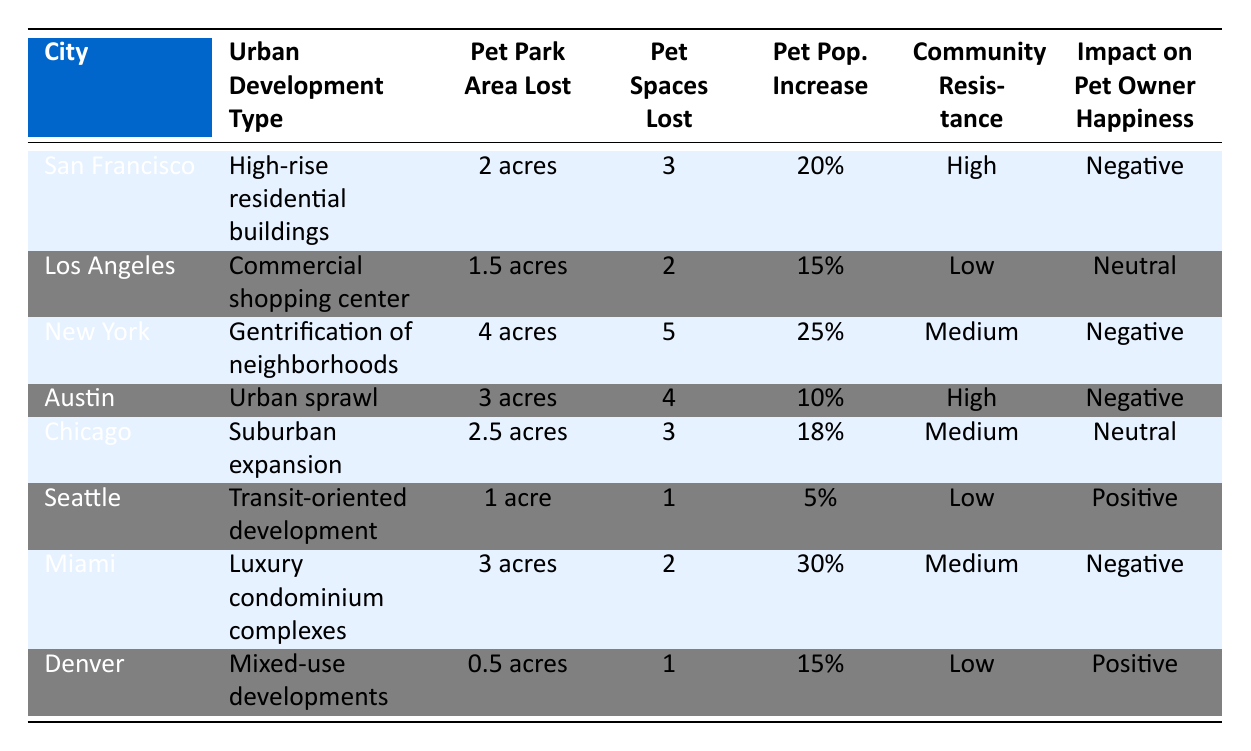What is the total pet park area lost in New York? From the table, the pet park area lost in New York is specified as 4 acres.
Answer: 4 acres How many pet friendly spaces were lost in Austin? The table indicates that 4 pet friendly spaces were lost in Austin.
Answer: 4 Which city experienced the highest increase in pet population? By comparing the increase in pet populations across cities, New York has the highest at 25%.
Answer: New York What's the average area of pet parks lost across all cities? To calculate the average, sum the pet park areas lost: (2 + 1.5 + 4 + 3 + 2.5 + 1 + 3 + 0.5) = 18.5 acres. There are 8 cities, so the average is 18.5/8 = 2.31 acres.
Answer: 2.31 acres Does the urban development in Seattle have a positive impact on pet owner happiness? According to the table, urban development in Seattle has a positive impact on pet owner happiness, as it is listed as positive.
Answer: Yes Which urban development type leads to the most negative impact on pet owner happiness? By reviewing the table, high-rise residential buildings, gentrification, urban sprawl, and luxury condominiums are all listed as negative; however, the most significant development type affecting happiness negatively can be inferred from the number of spaces lost, with gentrification resulting in the most spaces lost.
Answer: Gentrification of neighborhoods Is community resistance higher in San Francisco or Austin? The table lists community resistance as high for both San Francisco and Austin; therefore, they are the same.
Answer: They are the same Count how many cities have a neutral impact on pet owner happiness. The table indicates that only Los Angeles and Chicago have a neutral impact on pet owner happiness, counting the entries results in 2 cities.
Answer: 2 